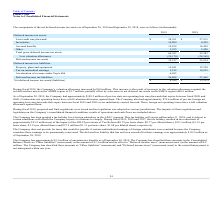According to Plexus's financial document, What was the change in the company's valuation allowance during Fiscal 2019? According to the financial document, 0.8 (in millions). The relevant text states: ", the Company’s valuation allowance increased by $0.8 million. This increase is the result of increases to the valuation allowances against the net defer..." Also, What was the amount of inventories in 2018? According to the financial document, 6,459 (in thousands). The relevant text states: "Inventories 16,809 6,459..." Also, What was the amount of Accrued benefits in 2019? According to the financial document, 15,834 (in thousands). The relevant text states: "Accrued benefits 15,834 14,459..." Also, How many years did the Loss/credit carryforwards exceed $25,000 thousand? Counting the relevant items in the document: 2019, 2018, I find 2 instances. The key data points involved are: 2018, 2019. Also, can you calculate: What was the change in the inventories between 2018 and 2019? Based on the calculation: 16,809-6,459, the result is 10350 (in thousands). This is based on the information: "Inventories 16,809 6,459 Inventories 16,809 6,459..." The key data points involved are: 16,809, 6,459. Also, can you calculate: What was the percentage change in the Property, plant and equipment between 2018 and 2019? To answer this question, I need to perform calculations using the financial data. The calculation is: (15,621-12,530)/12,530, which equals 24.67 (percentage). This is based on the information: "Property, plant and equipment 15,621 12,530 Property, plant and equipment 15,621 12,530..." The key data points involved are: 12,530, 15,621. 